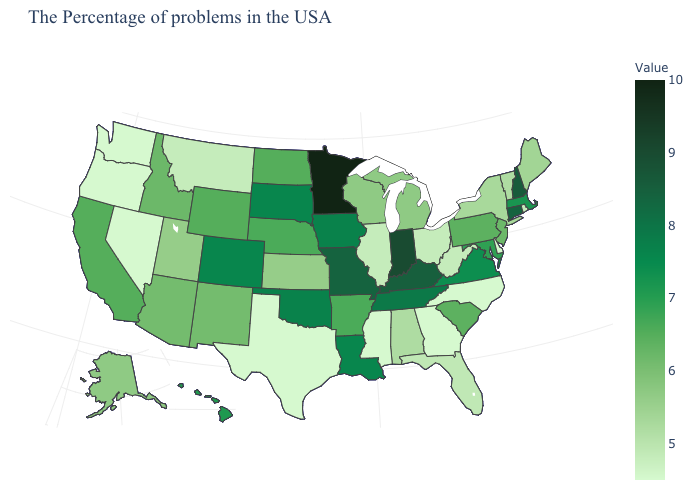Among the states that border Washington , which have the highest value?
Write a very short answer. Idaho. Does Washington have the lowest value in the West?
Give a very brief answer. Yes. Which states have the highest value in the USA?
Keep it brief. Minnesota. Which states have the highest value in the USA?
Answer briefly. Minnesota. 